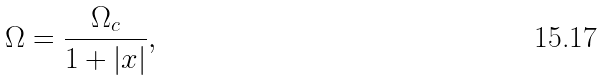Convert formula to latex. <formula><loc_0><loc_0><loc_500><loc_500>\Omega = \frac { \Omega _ { c } } { 1 + | x | } ,</formula> 